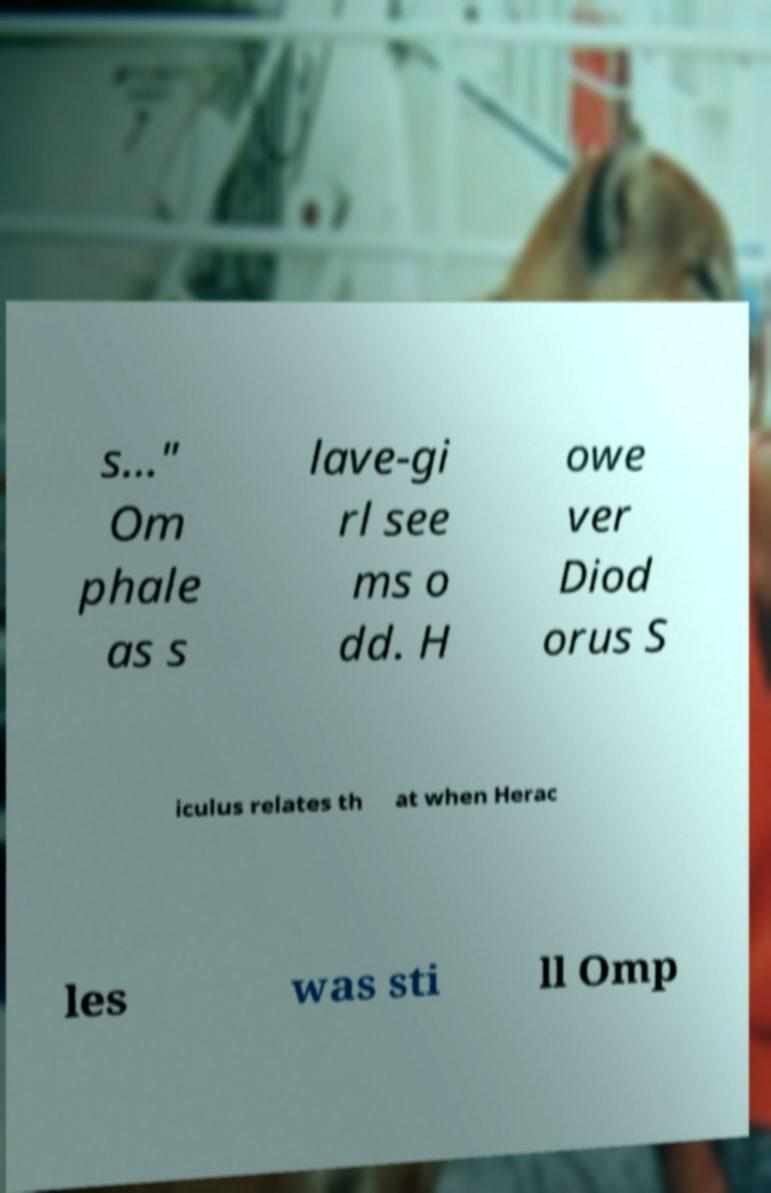Could you assist in decoding the text presented in this image and type it out clearly? s..." Om phale as s lave-gi rl see ms o dd. H owe ver Diod orus S iculus relates th at when Herac les was sti ll Omp 